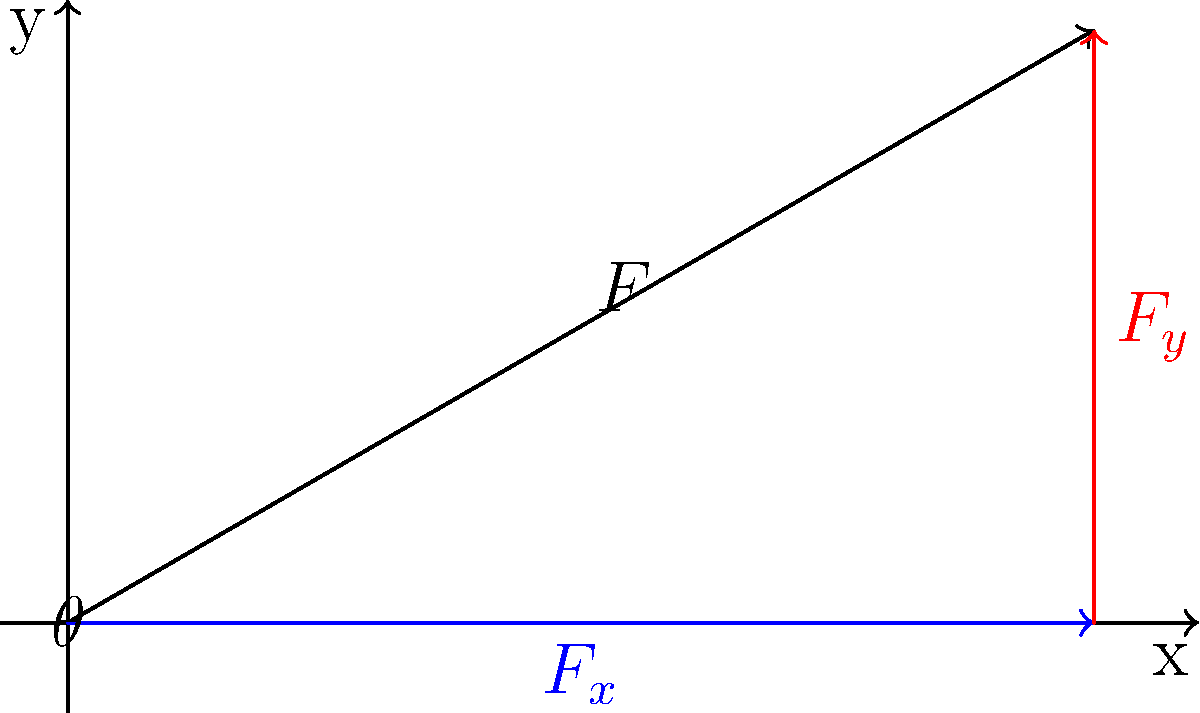In a slap shot, the force applied to the puck can be represented by a vector. If the total force applied is 500 N at an angle of 30° above the horizontal, what is the magnitude of the horizontal component of the force vector? To solve this problem, we'll follow these steps:

1. Identify the given information:
   - Total force (F) = 500 N
   - Angle (θ) = 30°

2. Recall the formula for the horizontal component of a force vector:
   $$F_x = F \cos(\theta)$$

3. Convert the angle from degrees to radians (if necessary for your calculator):
   $$30° = \frac{\pi}{6} \text{ radians}$$

4. Substitute the values into the formula:
   $$F_x = 500 \cos(30°)$$

5. Calculate the result:
   $$F_x = 500 \times 0.866 = 433 \text{ N}$$

The horizontal component of the force vector is approximately 433 N.
Answer: 433 N 